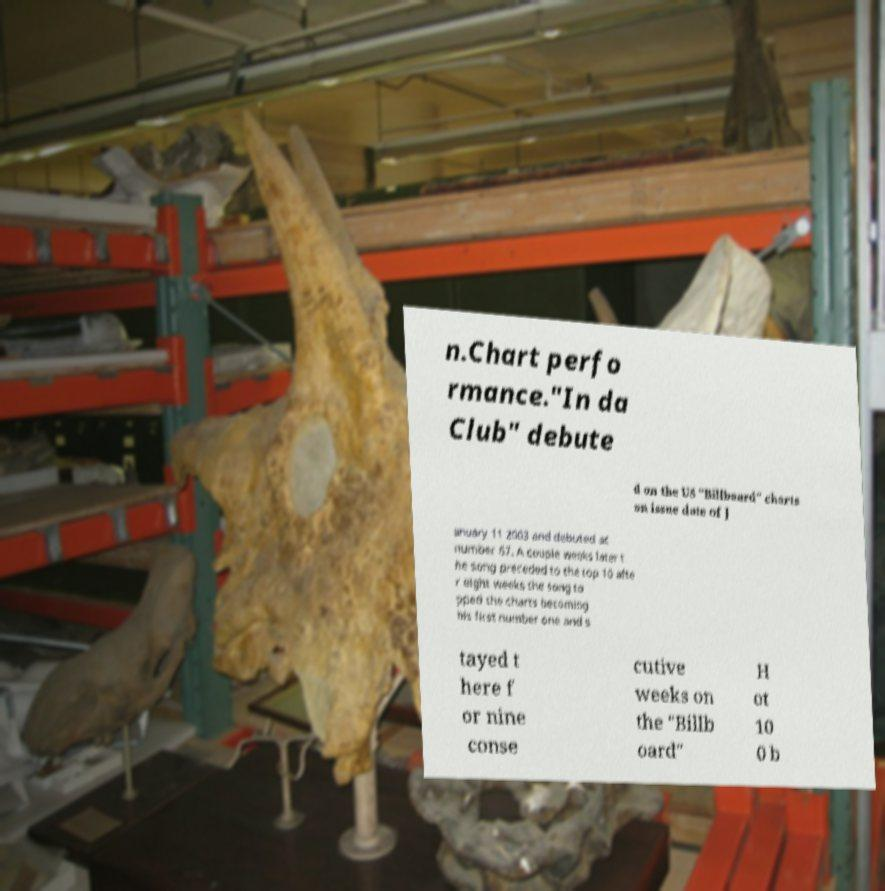Can you read and provide the text displayed in the image?This photo seems to have some interesting text. Can you extract and type it out for me? n.Chart perfo rmance."In da Club" debute d on the US "Billboard" charts on issue date of J anuary 11 2003 and debuted at number 67. A couple weeks later t he song preceded to the top 10 afte r eight weeks the song to pped the charts becoming his first number one and s tayed t here f or nine conse cutive weeks on the "Billb oard" H ot 10 0 b 